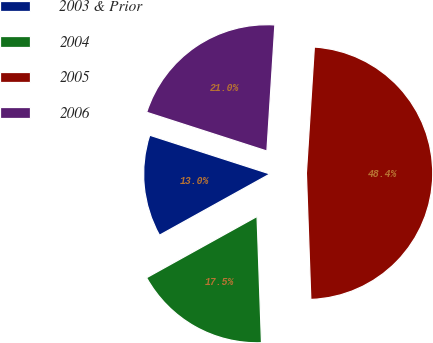<chart> <loc_0><loc_0><loc_500><loc_500><pie_chart><fcel>2003 & Prior<fcel>2004<fcel>2005<fcel>2006<nl><fcel>13.02%<fcel>17.5%<fcel>48.43%<fcel>21.04%<nl></chart> 